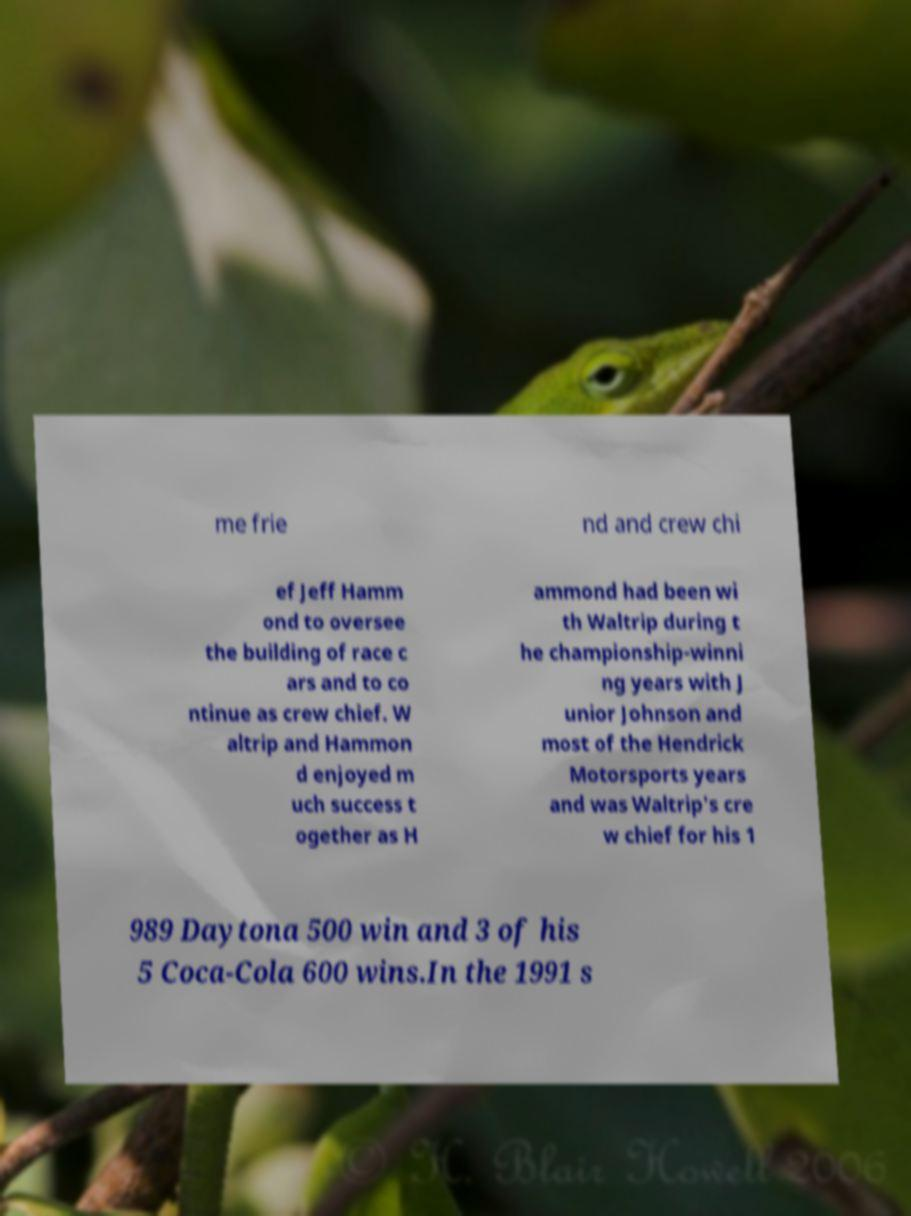Please read and relay the text visible in this image. What does it say? me frie nd and crew chi ef Jeff Hamm ond to oversee the building of race c ars and to co ntinue as crew chief. W altrip and Hammon d enjoyed m uch success t ogether as H ammond had been wi th Waltrip during t he championship-winni ng years with J unior Johnson and most of the Hendrick Motorsports years and was Waltrip's cre w chief for his 1 989 Daytona 500 win and 3 of his 5 Coca-Cola 600 wins.In the 1991 s 